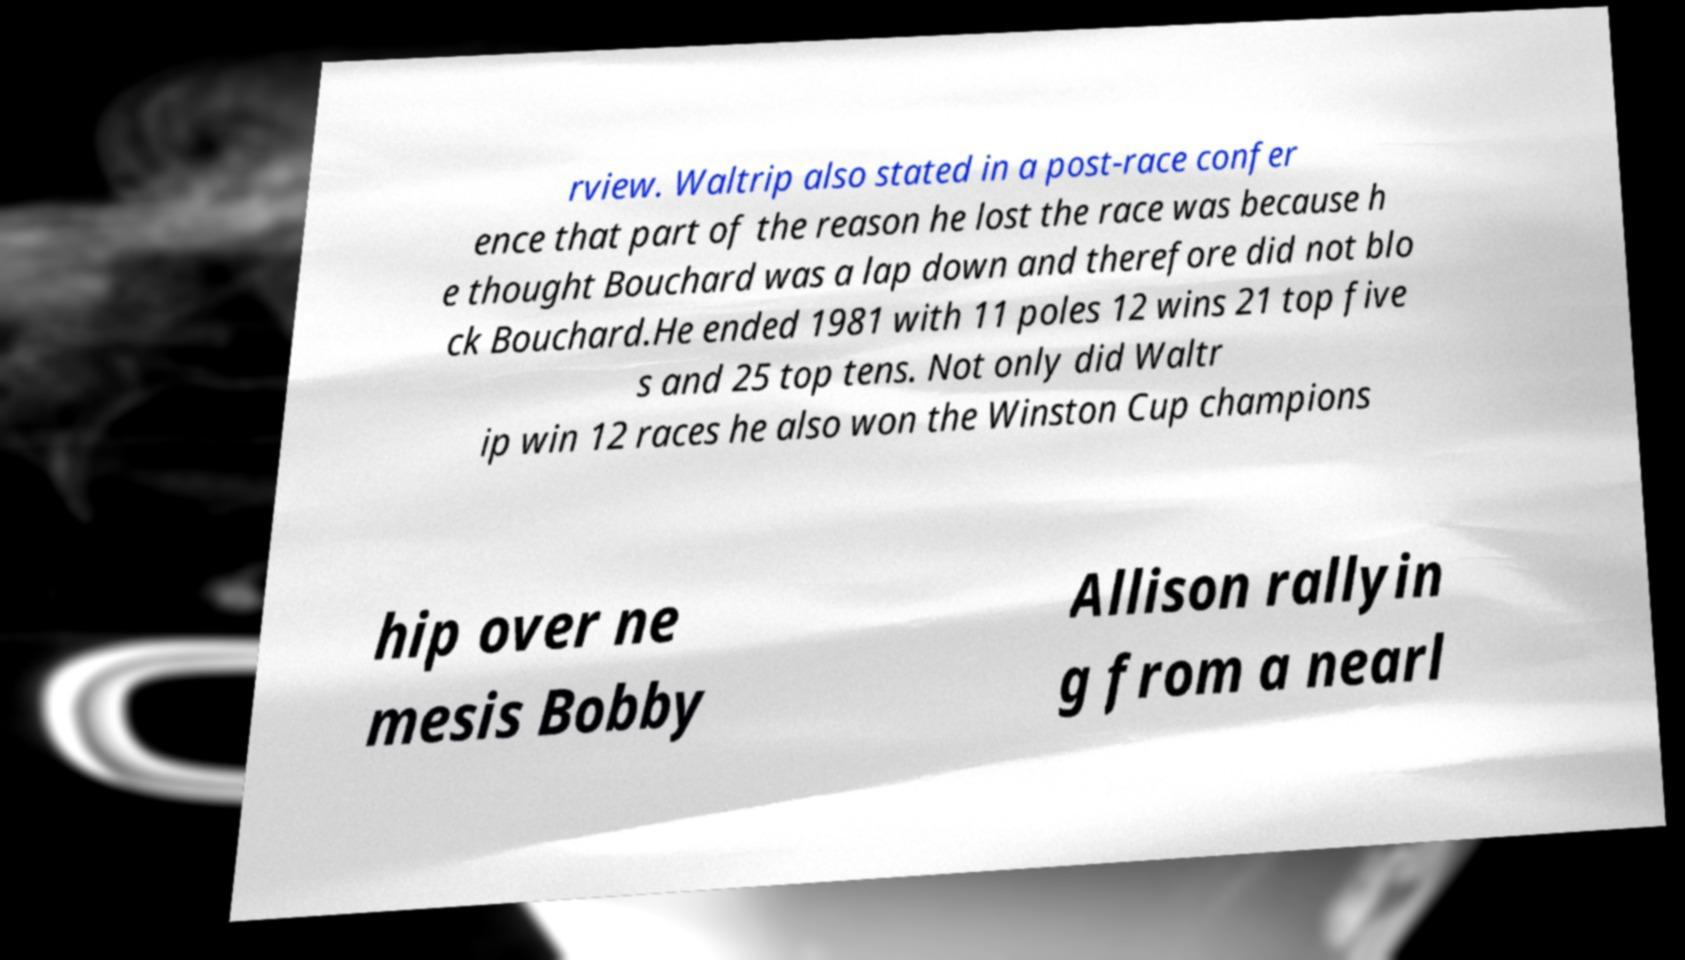There's text embedded in this image that I need extracted. Can you transcribe it verbatim? rview. Waltrip also stated in a post-race confer ence that part of the reason he lost the race was because h e thought Bouchard was a lap down and therefore did not blo ck Bouchard.He ended 1981 with 11 poles 12 wins 21 top five s and 25 top tens. Not only did Waltr ip win 12 races he also won the Winston Cup champions hip over ne mesis Bobby Allison rallyin g from a nearl 